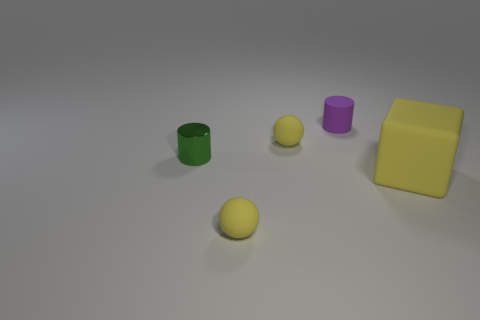Add 3 large red blocks. How many objects exist? 8 Subtract all cylinders. How many objects are left? 3 Subtract 1 purple cylinders. How many objects are left? 4 Subtract all shiny objects. Subtract all green things. How many objects are left? 3 Add 1 purple objects. How many purple objects are left? 2 Add 4 tiny blue blocks. How many tiny blue blocks exist? 4 